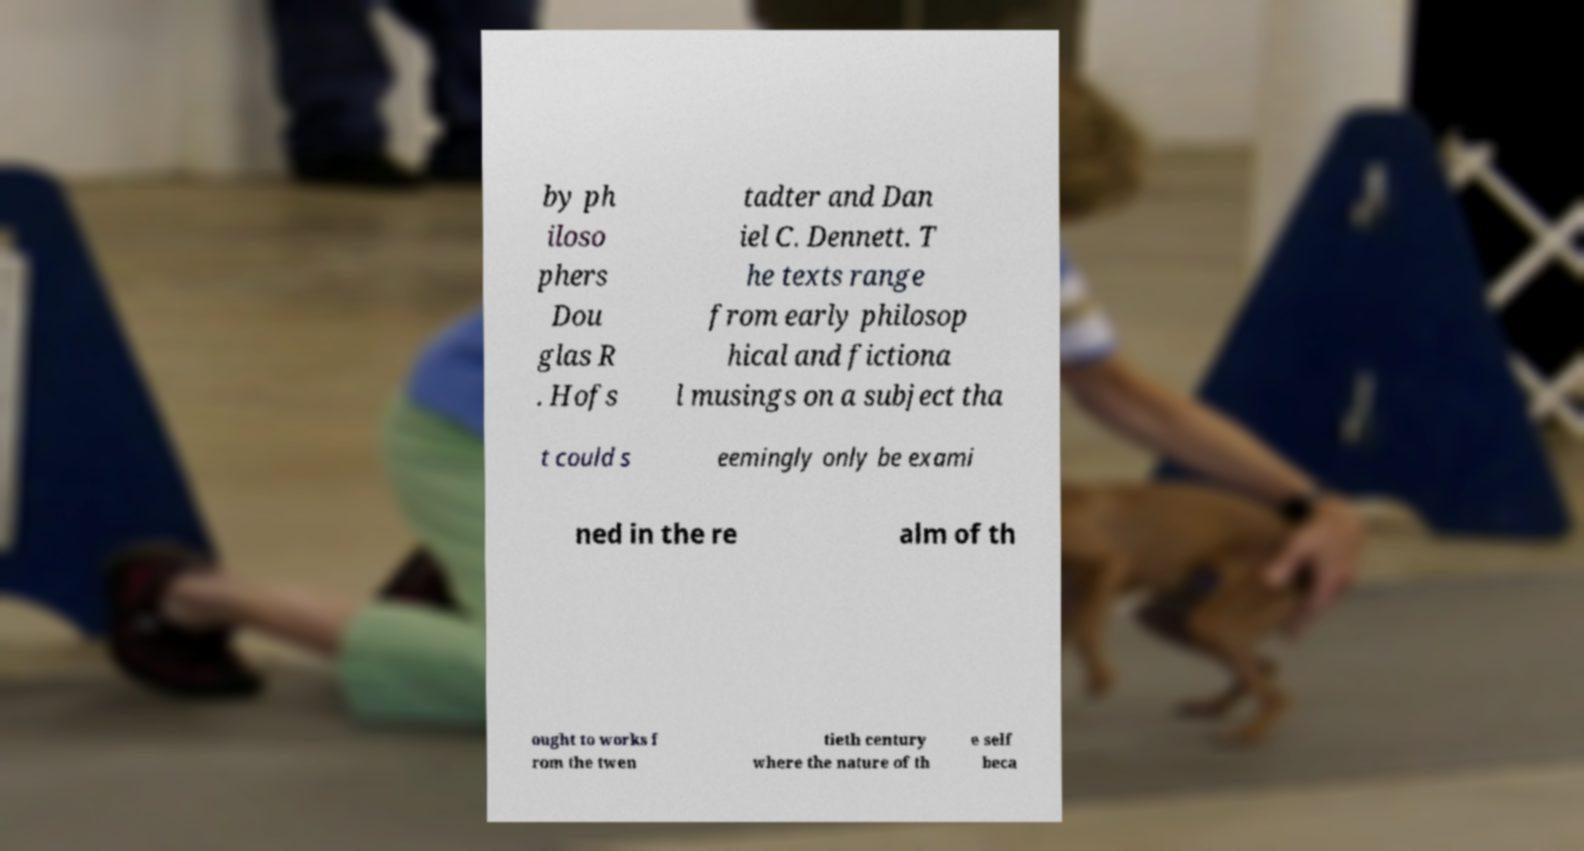Could you assist in decoding the text presented in this image and type it out clearly? by ph iloso phers Dou glas R . Hofs tadter and Dan iel C. Dennett. T he texts range from early philosop hical and fictiona l musings on a subject tha t could s eemingly only be exami ned in the re alm of th ought to works f rom the twen tieth century where the nature of th e self beca 